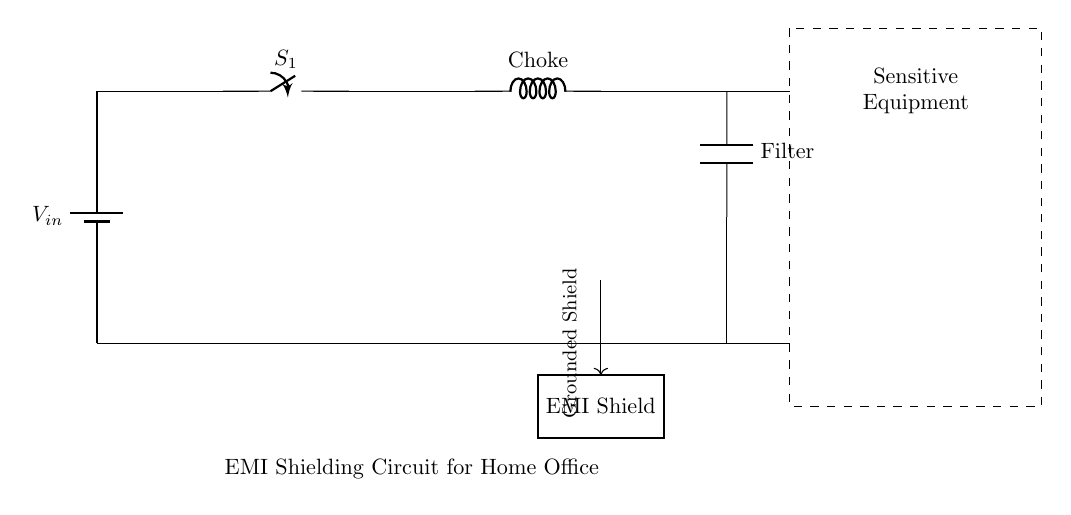What is the main function of the choke in this circuit? The choke serves to limit the amount of high-frequency noise that can pass through, providing EMI suppression.
Answer: EMI suppression What type of component is used for filtering in this circuit? The circuit includes a capacitor, which is specifically designated as the 'Filter' component to smooth out voltage fluctuations and reduce EMI.
Answer: Capacitor Which component provides a pathway to ground in this circuit? The 'Grounded Shield' is created to divert any electromagnetic interference away from the sensitive equipment, ensuring that it does not affect performance or operation.
Answer: Grounded Shield What does the switch labeled S1 control? The switch S1 can open or close the circuit, allowing the user to toggle the EMI shielding circuit on or off depending on whether protection is needed for the sensitive equipment.
Answer: EMI shielding on/off How is the sensitive equipment protected from electromagnetic interference? The EMI Shield is designed to block external electromagnetic fields while the choke and filter components work together to manage and reduce noise, providing comprehensive protection.
Answer: EMI Shield What is the relationship between the choke and the filter in this circuit? The choke is placed before the filter in the circuit path; it works to initially passively block high-frequency noise and then allows the filter to further smooth the remaining electrical signals.
Answer: Choke filters noise 